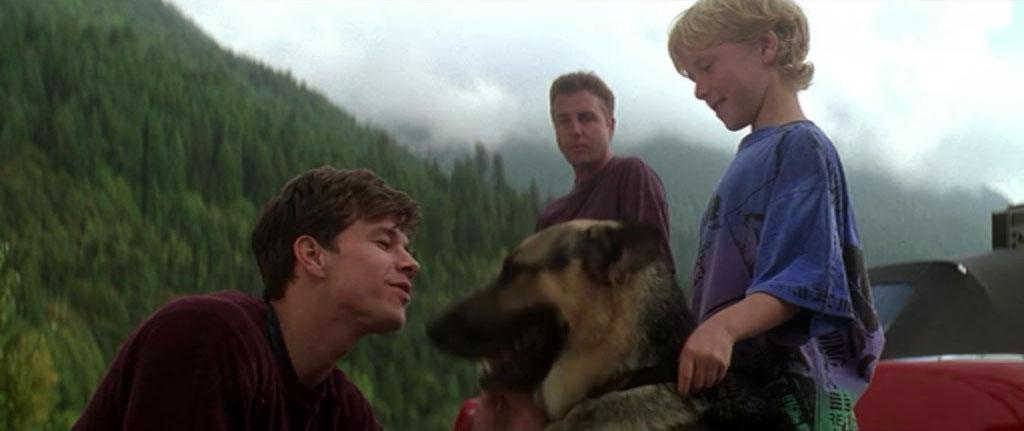How many people are present in the image? There are three people in the image. Can you describe the youngest person in the image? One of the people is a kid. What is the kid doing with his left hand? The kid is holding a dog with his left hand. What type of animal is present in the image? There is a dog in the image. What can be seen in the background of the image? There are trees, mountains, and the sky visible in the background of the image. What type of stamp can be seen on the dog's collar in the image? There is no stamp visible on the dog's collar in the image. image, and the dog is not wearing a collar. 